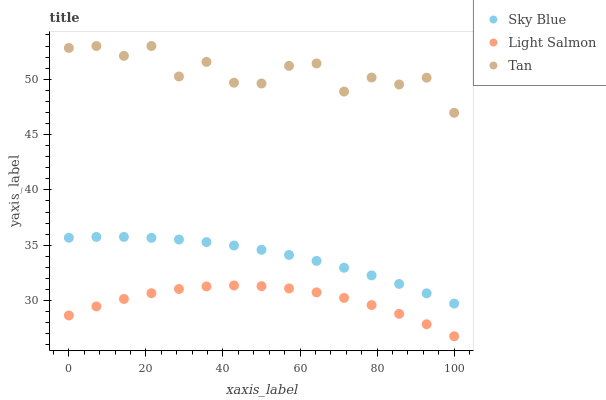Does Light Salmon have the minimum area under the curve?
Answer yes or no. Yes. Does Tan have the maximum area under the curve?
Answer yes or no. Yes. Does Tan have the minimum area under the curve?
Answer yes or no. No. Does Light Salmon have the maximum area under the curve?
Answer yes or no. No. Is Sky Blue the smoothest?
Answer yes or no. Yes. Is Tan the roughest?
Answer yes or no. Yes. Is Light Salmon the smoothest?
Answer yes or no. No. Is Light Salmon the roughest?
Answer yes or no. No. Does Light Salmon have the lowest value?
Answer yes or no. Yes. Does Tan have the lowest value?
Answer yes or no. No. Does Tan have the highest value?
Answer yes or no. Yes. Does Light Salmon have the highest value?
Answer yes or no. No. Is Light Salmon less than Sky Blue?
Answer yes or no. Yes. Is Tan greater than Sky Blue?
Answer yes or no. Yes. Does Light Salmon intersect Sky Blue?
Answer yes or no. No. 